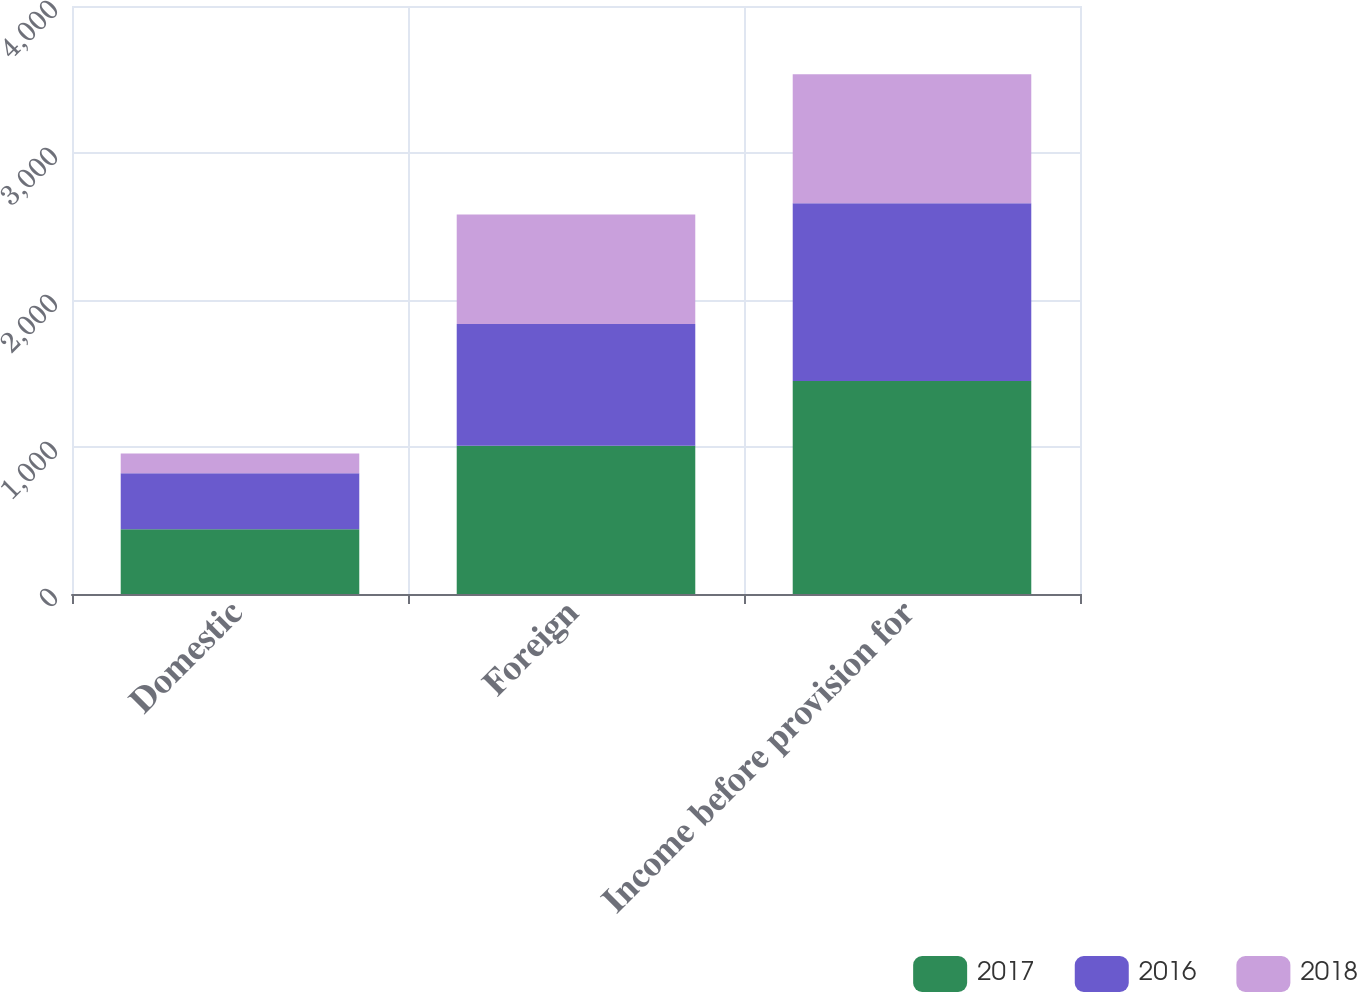Convert chart to OTSL. <chart><loc_0><loc_0><loc_500><loc_500><stacked_bar_chart><ecel><fcel>Domestic<fcel>Foreign<fcel>Income before provision for<nl><fcel>2017<fcel>440<fcel>1009<fcel>1449<nl><fcel>2016<fcel>382<fcel>828<fcel>1210<nl><fcel>2018<fcel>133<fcel>744<fcel>877<nl></chart> 